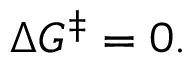<formula> <loc_0><loc_0><loc_500><loc_500>\Delta G ^ { \ddagger } = 0 .</formula> 